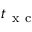<formula> <loc_0><loc_0><loc_500><loc_500>t _ { x c }</formula> 